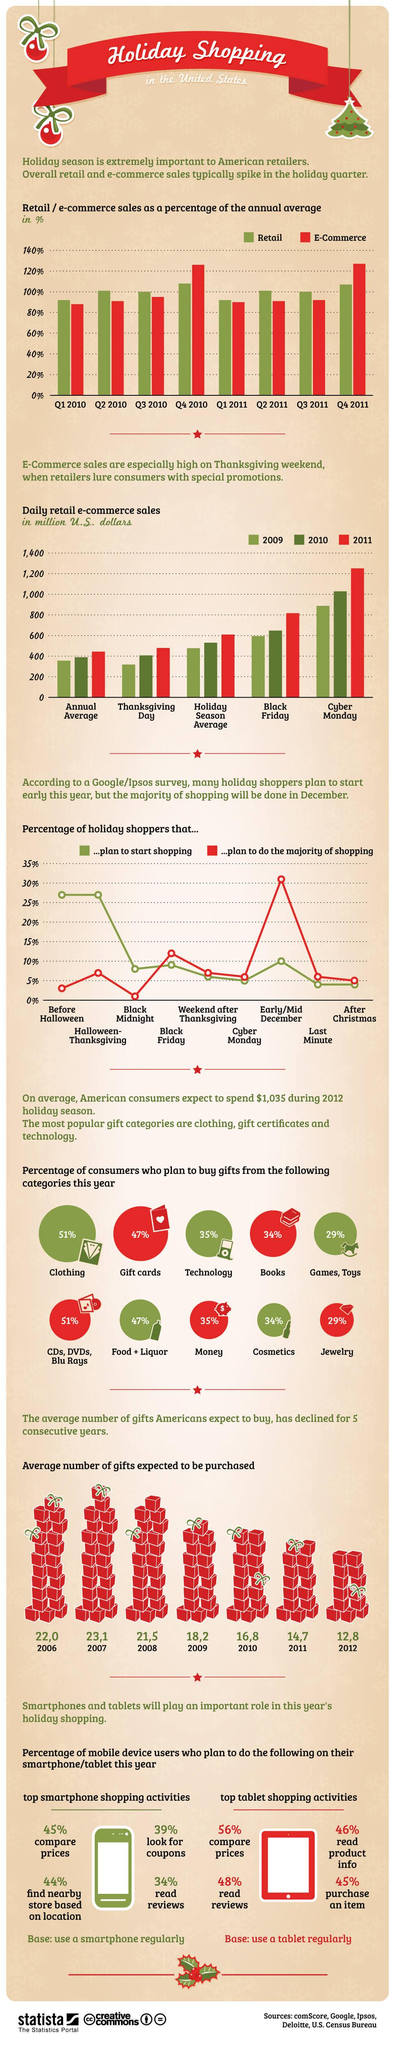Give some essential details in this illustration. In 2011, the Black Friday sales exceeded 800. In Q3 2011, the retail sales percentage was 100%. According to records, the lowest Thanksgiving Day sales were observed in 2009. According to a recent survey, a significant percentage of holiday shoppers plan to start shopping in early to mid-December. In the fourth quarter of 2011, E-commerce sales surpassed retail sales in terms of percentage growth. 